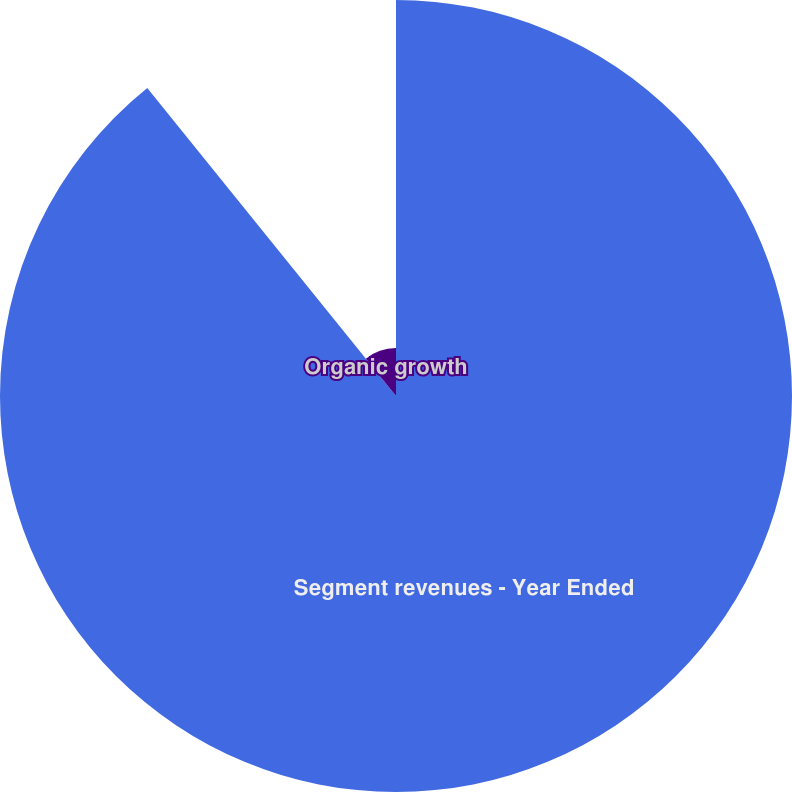<chart> <loc_0><loc_0><loc_500><loc_500><pie_chart><fcel>Segment revenues - Year Ended<fcel>Organic growth<nl><fcel>89.19%<fcel>10.81%<nl></chart> 